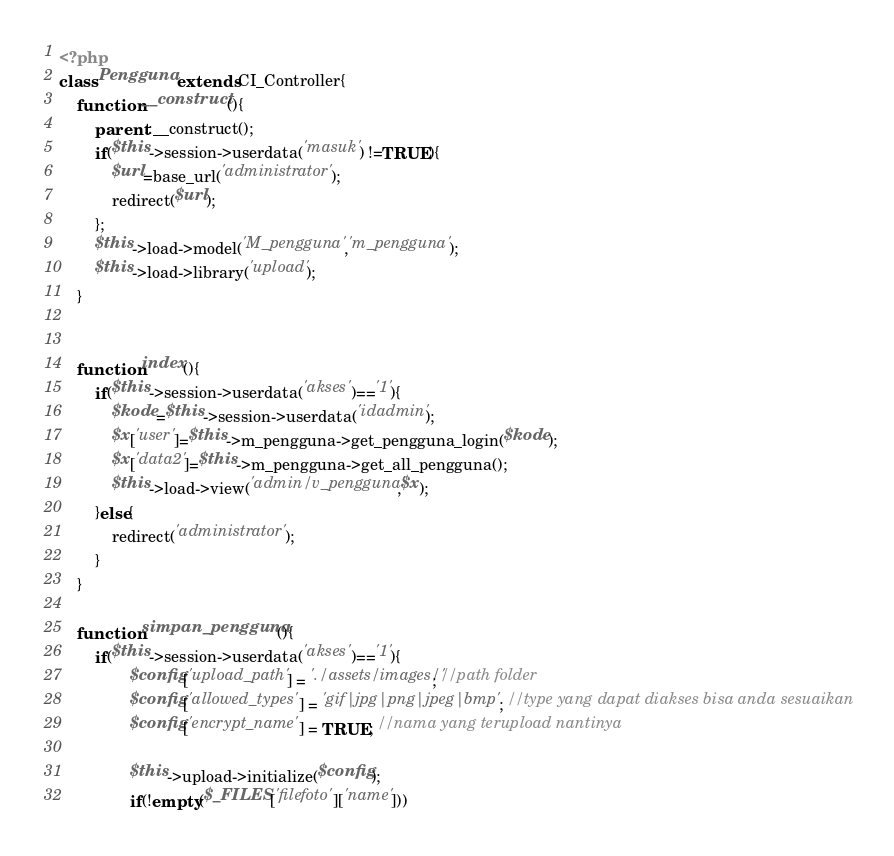Convert code to text. <code><loc_0><loc_0><loc_500><loc_500><_PHP_><?php
class Pengguna extends CI_Controller{
	function __construct(){
		parent::__construct();
		if($this->session->userdata('masuk') !=TRUE){
            $url=base_url('administrator');
            redirect($url);
        };
		$this->load->model('M_pengguna','m_pengguna');
		$this->load->library('upload');
	}


	function index(){
		if($this->session->userdata('akses')=='1'){
			$kode=$this->session->userdata('idadmin');
			$x['user']=$this->m_pengguna->get_pengguna_login($kode);
			$x['data2']=$this->m_pengguna->get_all_pengguna();
			$this->load->view('admin/v_pengguna',$x);
		}else{
            redirect('administrator');
        }
	}

	function simpan_pengguna(){
		if($this->session->userdata('akses')=='1'){
	            $config['upload_path'] = './assets/images/'; //path folder
	            $config['allowed_types'] = 'gif|jpg|png|jpeg|bmp'; //type yang dapat diakses bisa anda sesuaikan
	            $config['encrypt_name'] = TRUE; //nama yang terupload nantinya

	            $this->upload->initialize($config);
	            if(!empty($_FILES['filefoto']['name']))</code> 